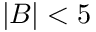<formula> <loc_0><loc_0><loc_500><loc_500>| B | < 5</formula> 